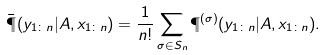<formula> <loc_0><loc_0><loc_500><loc_500>\bar { \P } ( y _ { 1 \colon n } | A , x _ { 1 \colon n } ) = \frac { 1 } { n ! } \sum _ { \sigma \in S _ { n } } \P ^ { ( \sigma ) } ( y _ { 1 \colon n } | A , x _ { 1 \colon n } ) .</formula> 